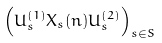Convert formula to latex. <formula><loc_0><loc_0><loc_500><loc_500>\left ( U _ { s } ^ { ( 1 ) } X _ { s } ( n ) U _ { s } ^ { ( 2 ) } \right ) _ { s \in S }</formula> 